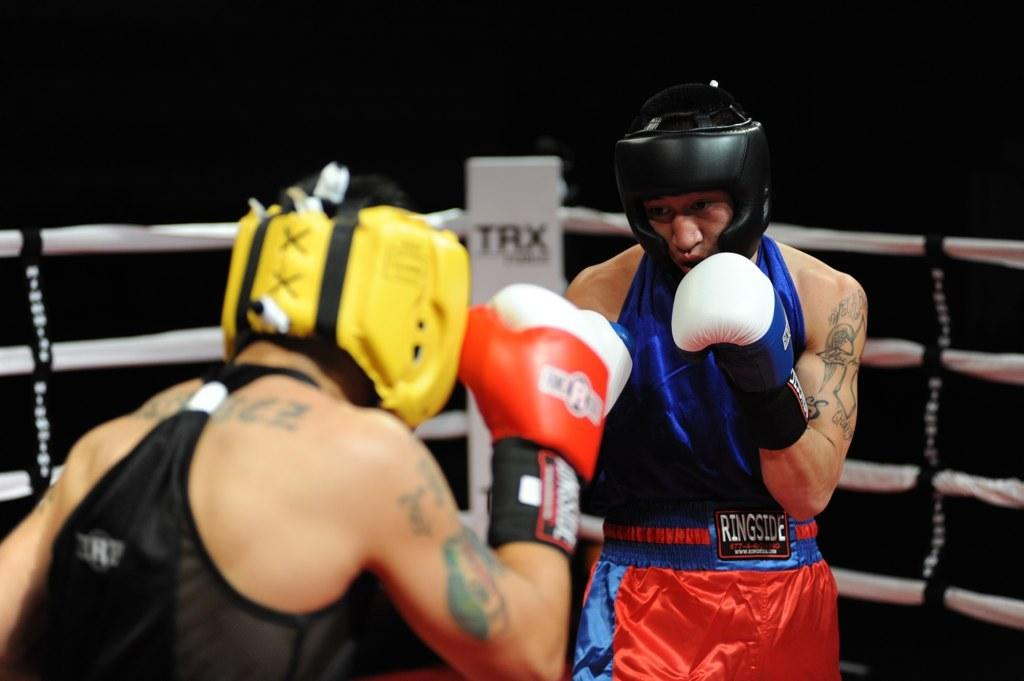How many people are in the image? There are two people in the image. What are the people doing in the image? The people are standing in the image. What are the people wearing on their heads? The people are wearing helmets in the image. What are the people wearing on their hands? The people are wearing gloves in the image. What is the setting of the image? There is a boxing-ring in the image. What is the color of the background in the image? The background of the image is black. What type of pickle is being used as a prop in the image? There is no pickle present in the image. What is the hairstyle of the expert in the image? There is no expert present in the image. 